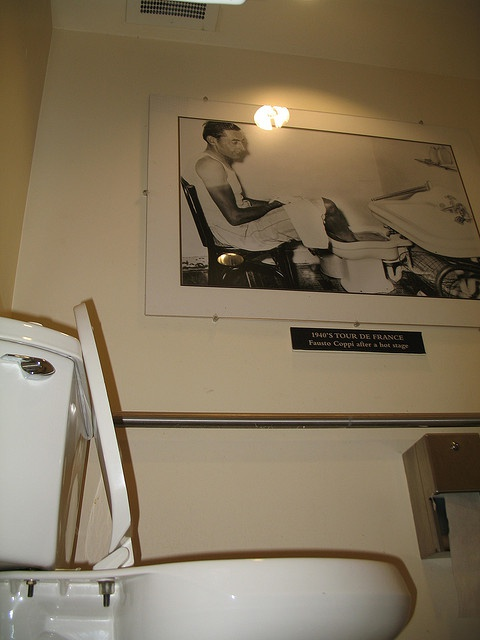Describe the objects in this image and their specific colors. I can see toilet in black, darkgray, lightgray, and gray tones, people in black and gray tones, and sink in black and gray tones in this image. 